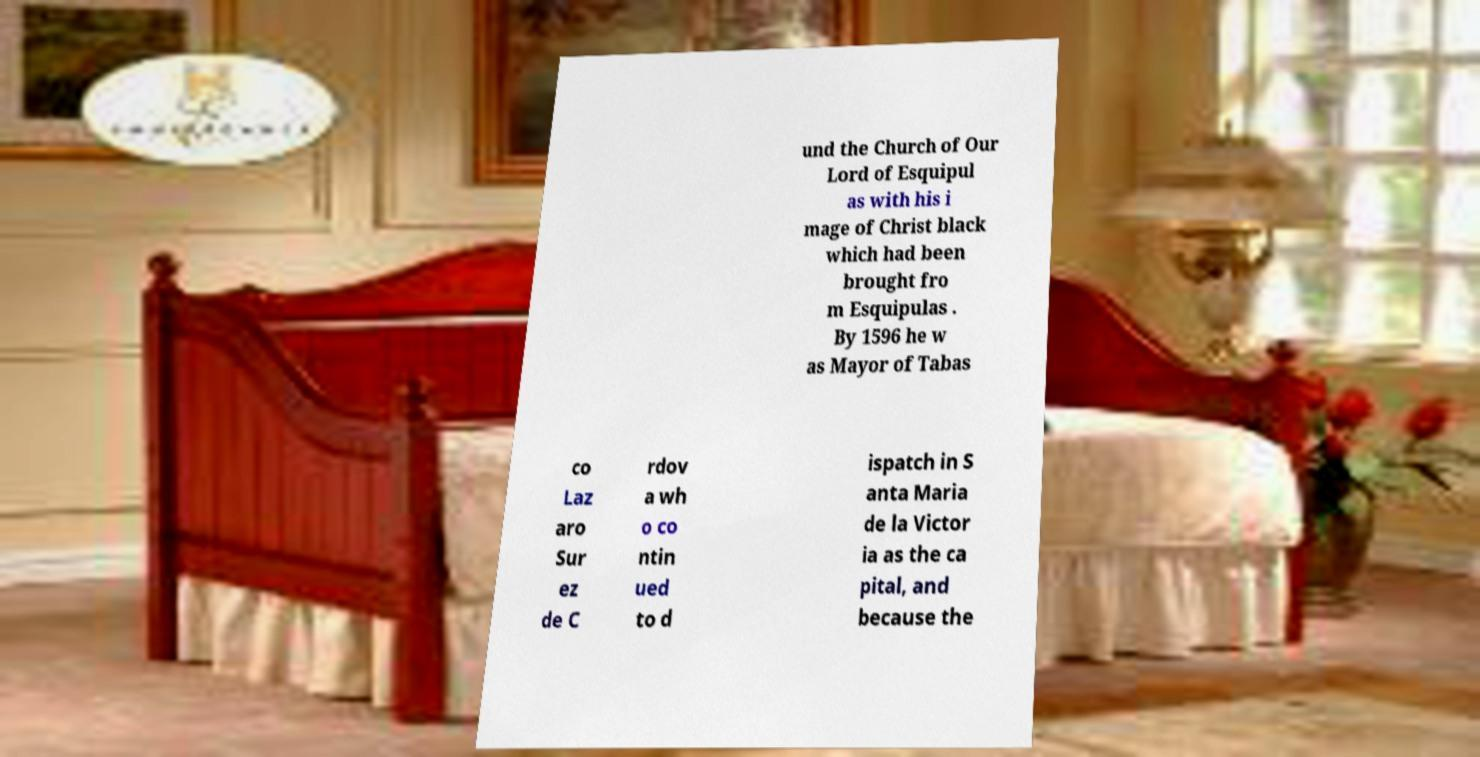Can you accurately transcribe the text from the provided image for me? und the Church of Our Lord of Esquipul as with his i mage of Christ black which had been brought fro m Esquipulas . By 1596 he w as Mayor of Tabas co Laz aro Sur ez de C rdov a wh o co ntin ued to d ispatch in S anta Maria de la Victor ia as the ca pital, and because the 